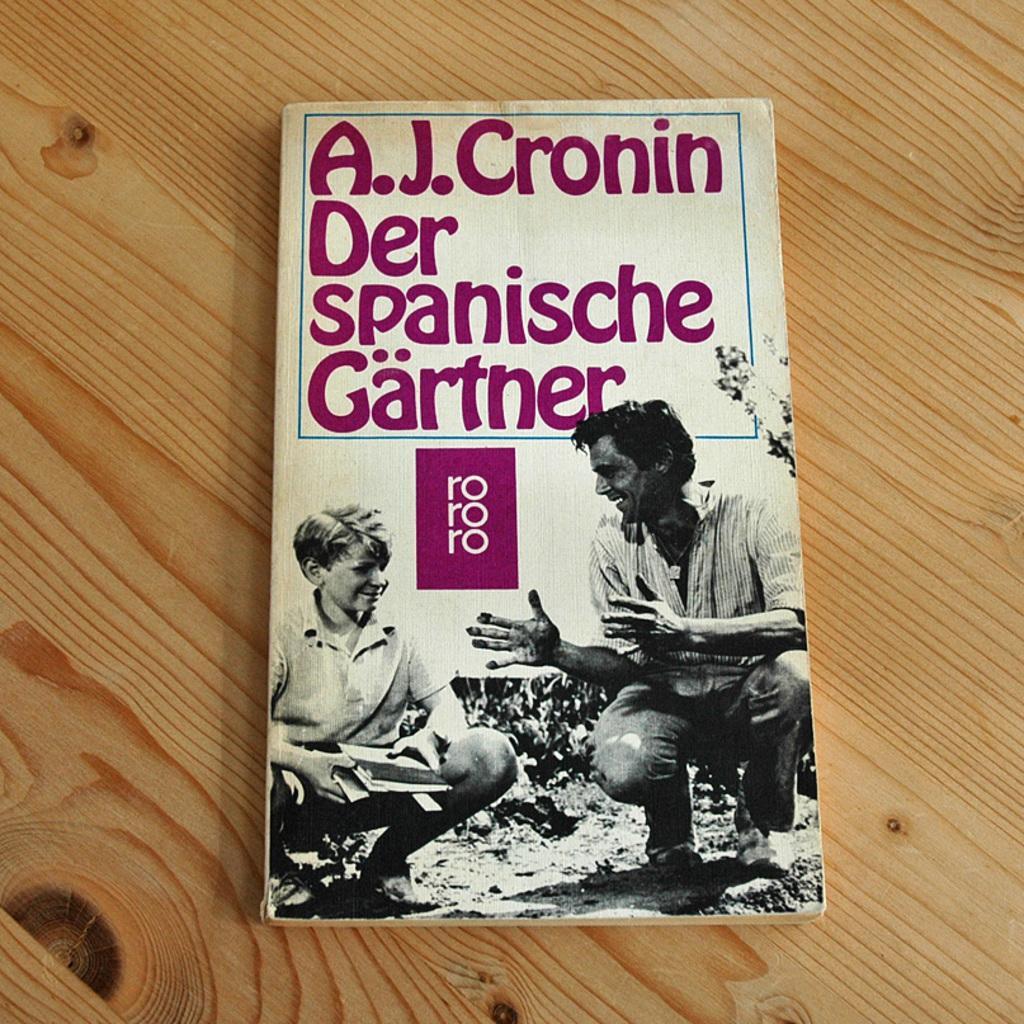Please provide a concise description of this image. In this picture there is a book which is kept on the table. In that book cover i can see two persons were in squat position and both of are smiling. At the top of the book i can see the content name. 